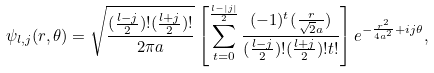<formula> <loc_0><loc_0><loc_500><loc_500>\psi _ { l , j } ( r , \theta ) = \sqrt { \frac { ( \frac { l - j } { 2 } ) ! ( \frac { l + j } { 2 } ) ! } { 2 \pi a } } \left [ \sum ^ { \frac { l - | j | } { 2 } } _ { t = 0 } \frac { ( - 1 ) ^ { t } ( \frac { r } { \sqrt { 2 } a } ) } { ( \frac { l - j } { 2 } ) ! ( \frac { l + j } { 2 } ) ! t ! } \right ] e ^ { - \frac { r ^ { 2 } } { 4 a ^ { 2 } } + i j \theta } ,</formula> 